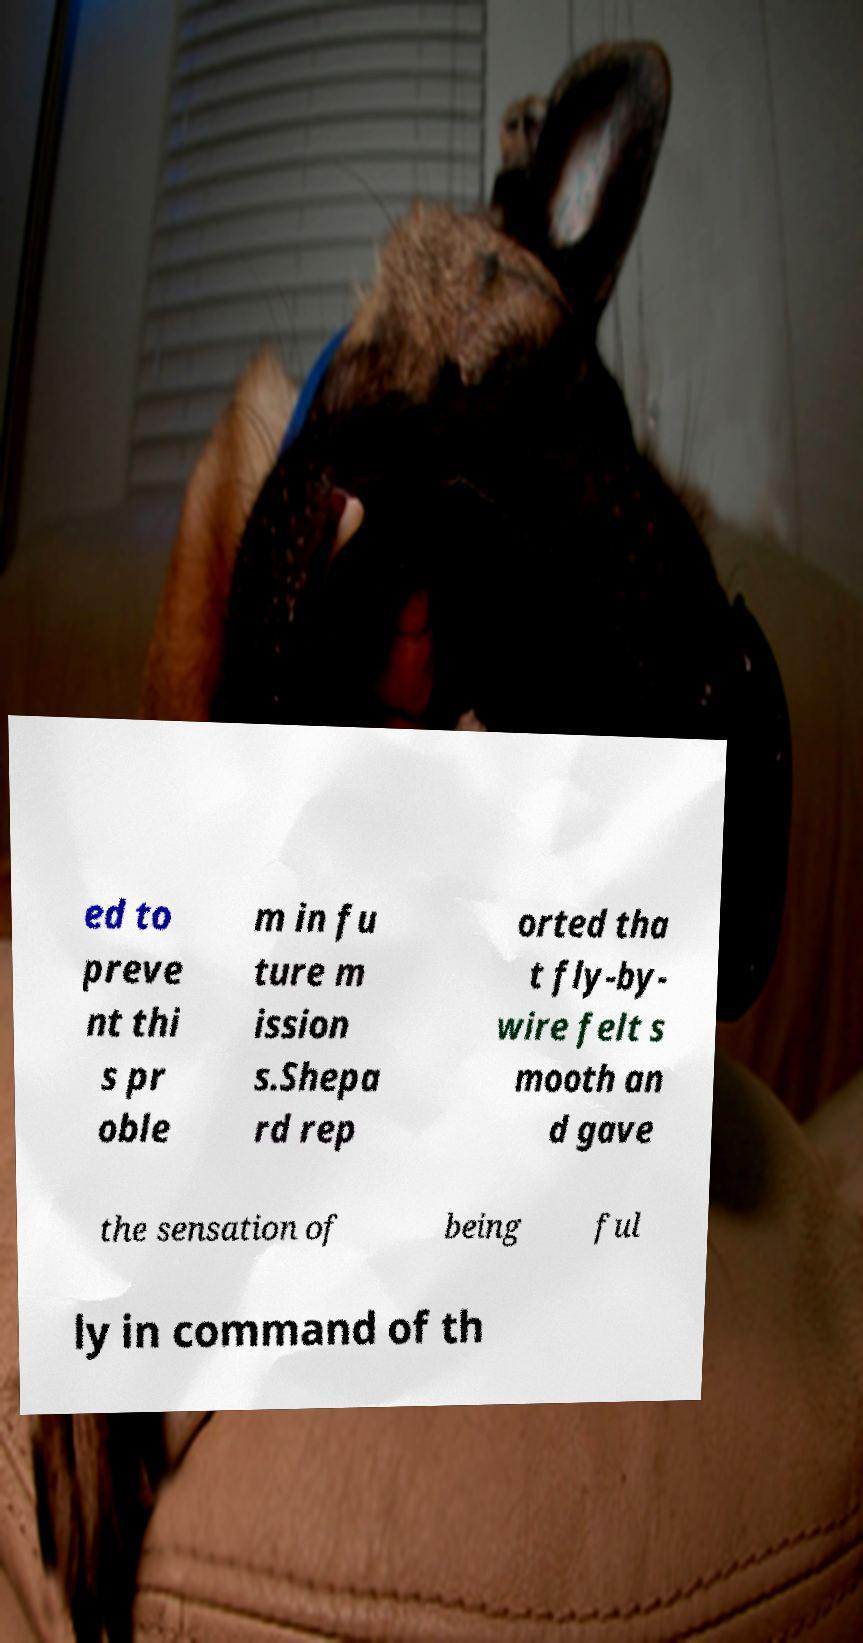Please read and relay the text visible in this image. What does it say? ed to preve nt thi s pr oble m in fu ture m ission s.Shepa rd rep orted tha t fly-by- wire felt s mooth an d gave the sensation of being ful ly in command of th 